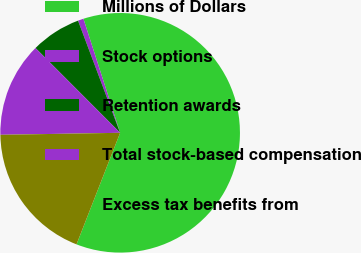Convert chart to OTSL. <chart><loc_0><loc_0><loc_500><loc_500><pie_chart><fcel>Millions of Dollars<fcel>Stock options<fcel>Retention awards<fcel>Total stock-based compensation<fcel>Excess tax benefits from<nl><fcel>60.89%<fcel>0.76%<fcel>6.77%<fcel>12.78%<fcel>18.8%<nl></chart> 